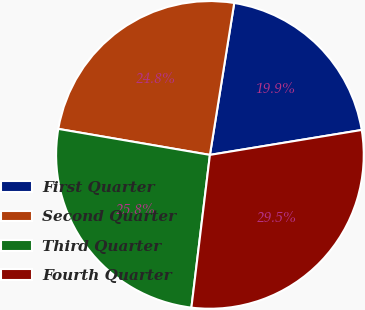<chart> <loc_0><loc_0><loc_500><loc_500><pie_chart><fcel>First Quarter<fcel>Second Quarter<fcel>Third Quarter<fcel>Fourth Quarter<nl><fcel>19.88%<fcel>24.82%<fcel>25.78%<fcel>29.51%<nl></chart> 